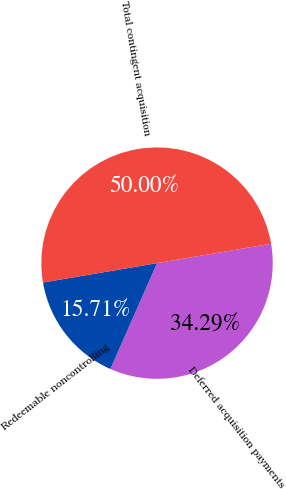<chart> <loc_0><loc_0><loc_500><loc_500><pie_chart><fcel>Deferred acquisition payments<fcel>Redeemable noncontrolling<fcel>Total contingent acquisition<nl><fcel>34.29%<fcel>15.71%<fcel>50.0%<nl></chart> 